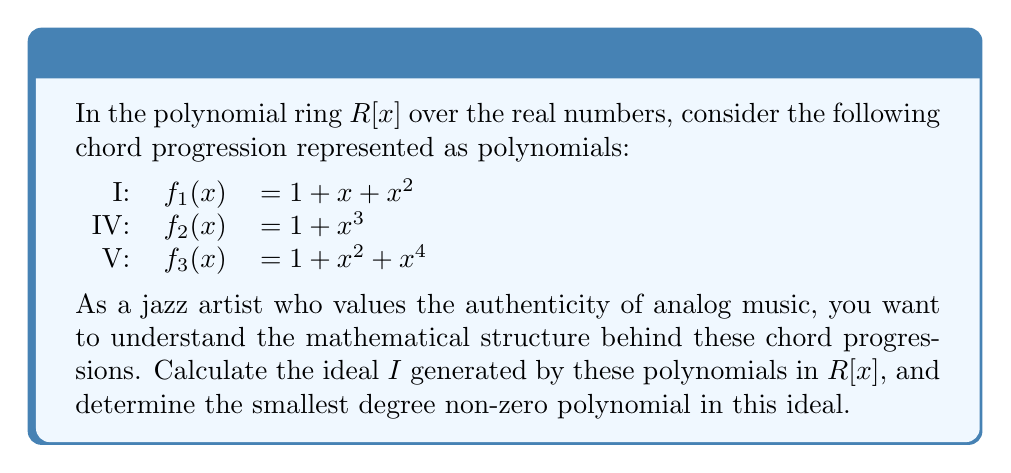Solve this math problem. To solve this problem, we'll follow these steps:

1) The ideal $I$ generated by $f_1(x)$, $f_2(x)$, and $f_3(x)$ is defined as:

   $I = \{r_1(x)f_1(x) + r_2(x)f_2(x) + r_3(x)f_3(x) | r_1(x), r_2(x), r_3(x) \in R[x]\}$

2) To find the smallest degree non-zero polynomial in $I$, we need to find the greatest common divisor (GCD) of $f_1(x)$, $f_2(x)$, and $f_3(x)$.

3) Let's use the Euclidean algorithm:

   $f_1(x) = 1 + x + x^2$
   $f_2(x) = 1 + x^3$
   $f_3(x) = 1 + x^2 + x^4$

   First, let's find GCD($f_1(x)$, $f_2(x)$):
   $f_2(x) = (x-1)f_1(x) + (2-x)$
   $f_1(x) = (x+1)(2-x) + 1$

   So, GCD($f_1(x)$, $f_2(x)$) = 1

4) Now, let's find GCD(1, $f_3(x)$):
   Obviously, GCD(1, $f_3(x)$) = 1

5) Therefore, the GCD of all three polynomials is 1.

6) This means that the ideal $I$ is the entire ring $R[x]$, and the smallest degree non-zero polynomial in $I$ is the constant polynomial 1.
Answer: 1 